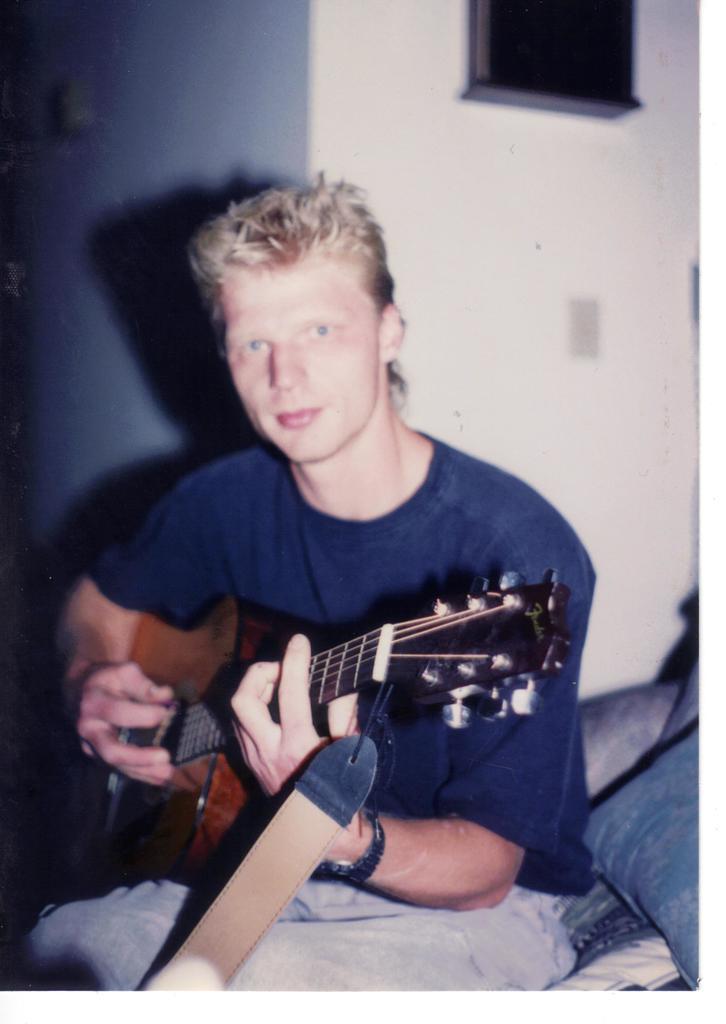Could you give a brief overview of what you see in this image? In this image a person holding a a guitar wearing a blue color t-shirt ,his sitting on the bed,on the bed there is a pillow And back side of him there is a wall. 